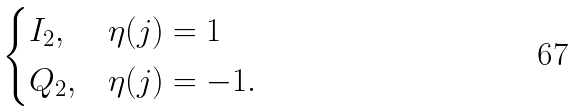Convert formula to latex. <formula><loc_0><loc_0><loc_500><loc_500>\begin{cases} I _ { 2 } , & \eta ( j ) = 1 \\ Q _ { 2 } , & \eta ( j ) = - 1 . \end{cases}</formula> 